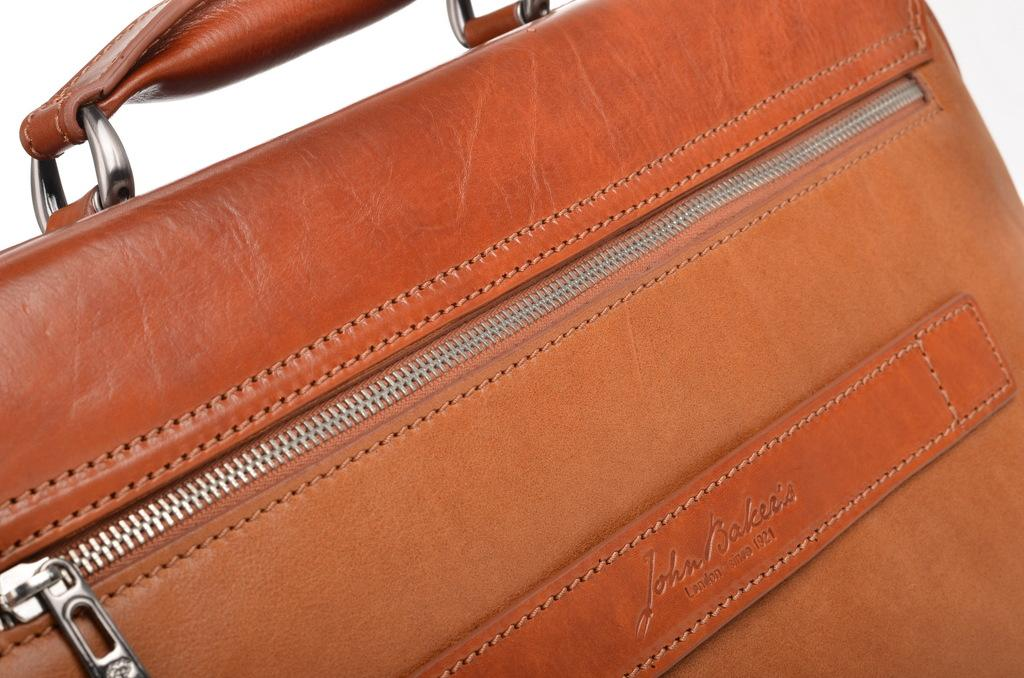What object can be seen in the image? There is a bag in the image. What color is the bag? The bag is orange in color. Is there a light shining from the cave in the image? There is no cave or light present in the image; it only features a bag. 